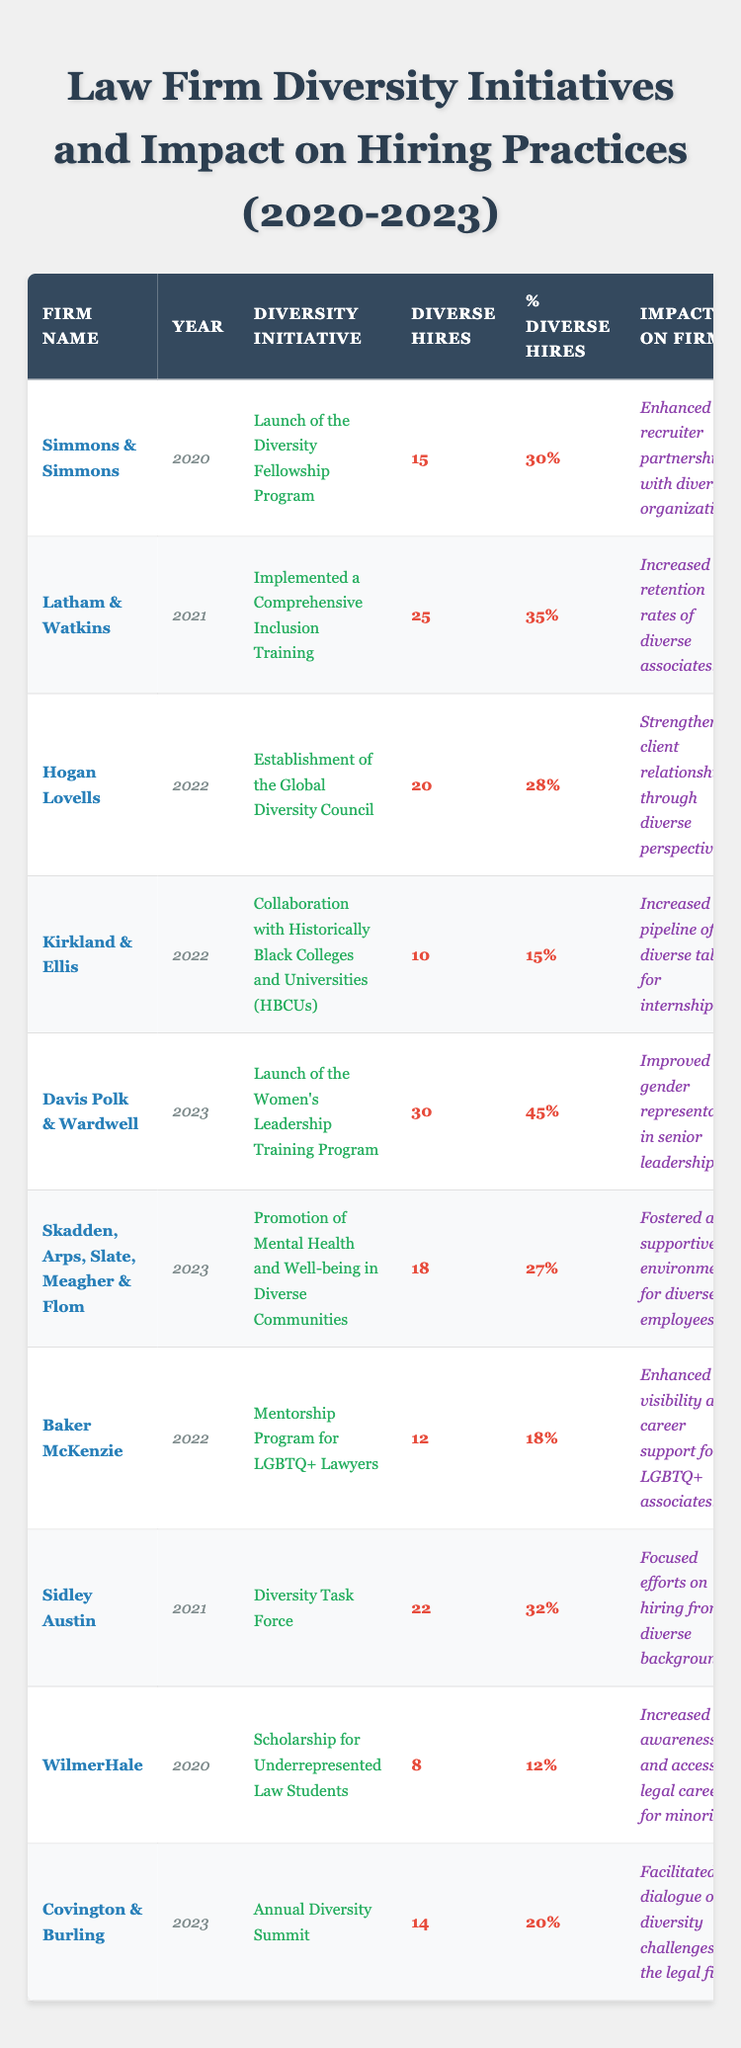What was the diversity initiative introduced by WilmerHale in 2020? WilmerHale launched a scholarship for underrepresented law students in 2020 as part of their diversity initiative.
Answer: Scholarship for Underrepresented Law Students How many diverse hires did Davis Polk & Wardwell achieve in 2023? Davis Polk & Wardwell achieved 30 diverse hires in 2023, as stated in the table.
Answer: 30 Which law firm had the highest percentage of diverse hires in 2023? Davis Polk & Wardwell had the highest percentage of diverse hires at 45% in 2023.
Answer: Davis Polk & Wardwell What is the total number of diverse hires reported from all firms in 2022? Summing the diverse hires from 2022: 20 (Hogan Lovells) + 10 (Kirkland & Ellis) + 12 (Baker McKenzie) = 42.
Answer: 42 Did Latham & Watkins' initiative in 2021 lead to an increase in retention rates? Yes, the initiative implemented by Latham & Watkins in 2021 aimed at increasing retention rates of diverse associates.
Answer: Yes How many firms implemented initiatives in 2022 and what are their names? The firms that implemented initiatives in 2022 are Hogan Lovells, Kirkland & Ellis, and Baker McKenzie, giving a total of three firms.
Answer: 3 firms: Hogan Lovells, Kirkland & Ellis, Baker McKenzie What percentage of diverse hires did Baker McKenzie achieve in 2022? Baker McKenzie achieved 18% percentage of diverse hires in 2022, as shown in the table.
Answer: 18% Compare the number of diverse hires between Simmons & Simmons in 2020 and Skadden, Arps, Slate, Meagher & Flom in 2023. Simmons & Simmons had 15 diverse hires in 2020, while Skadden, Arps, Slate, Meagher & Flom had 18 diverse hires in 2023. Therefore, Skadden had 3 more diverse hires.
Answer: Skadden had 3 more diverse hires What was the impact on the firm resulting from the Diversity Fellowship Program by Simmons & Simmons? The impact reported from the Diversity Fellowship Program was enhanced recruiter partnerships with diverse organizations.
Answer: Enhanced recruiter partnerships What was the total number of diverse hires across all firms in 2021? Adding the diverse hires from 2021: 25 (Latham & Watkins) + 22 (Sidley Austin) = 47 gives a total of 47 diverse hires in that year.
Answer: 47 